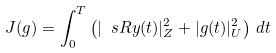Convert formula to latex. <formula><loc_0><loc_0><loc_500><loc_500>J ( g ) = \int _ { 0 } ^ { T } \left ( | \ s R y ( t ) | _ { Z } ^ { 2 } + | g ( t ) | _ { U } ^ { 2 } \right ) \, d t</formula> 